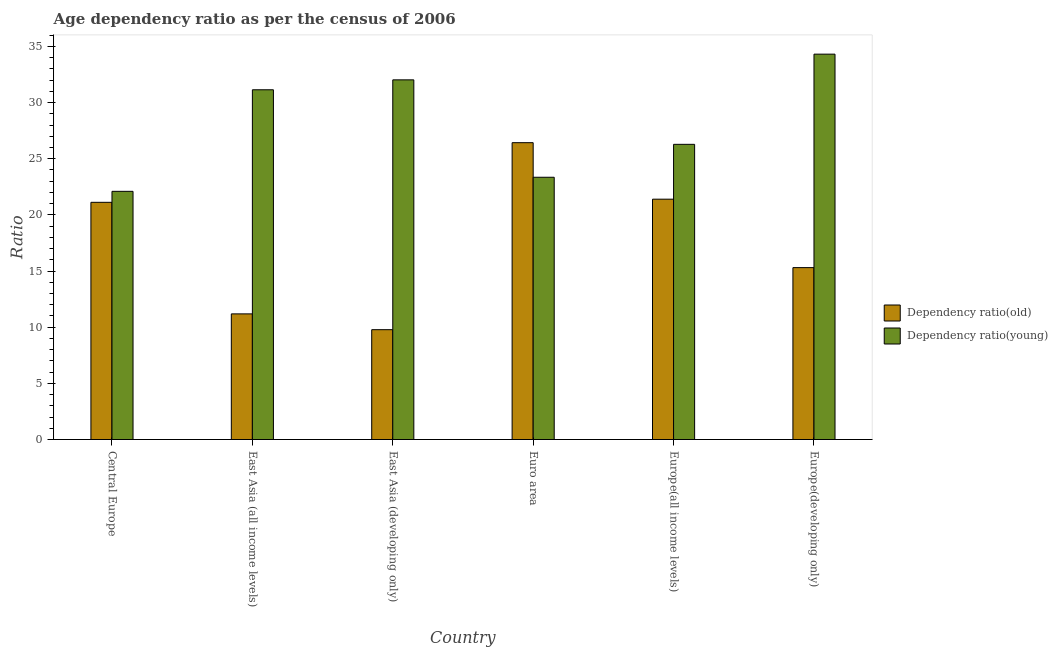How many different coloured bars are there?
Your answer should be compact. 2. How many groups of bars are there?
Ensure brevity in your answer.  6. How many bars are there on the 2nd tick from the left?
Provide a succinct answer. 2. What is the label of the 3rd group of bars from the left?
Keep it short and to the point. East Asia (developing only). In how many cases, is the number of bars for a given country not equal to the number of legend labels?
Your answer should be compact. 0. What is the age dependency ratio(old) in Euro area?
Give a very brief answer. 26.43. Across all countries, what is the maximum age dependency ratio(young)?
Provide a short and direct response. 34.31. Across all countries, what is the minimum age dependency ratio(old)?
Offer a very short reply. 9.78. In which country was the age dependency ratio(old) maximum?
Give a very brief answer. Euro area. In which country was the age dependency ratio(old) minimum?
Give a very brief answer. East Asia (developing only). What is the total age dependency ratio(old) in the graph?
Give a very brief answer. 105.21. What is the difference between the age dependency ratio(old) in Euro area and that in Europe(all income levels)?
Provide a short and direct response. 5.03. What is the difference between the age dependency ratio(young) in Euro area and the age dependency ratio(old) in East Asia (developing only)?
Ensure brevity in your answer.  13.57. What is the average age dependency ratio(old) per country?
Give a very brief answer. 17.54. What is the difference between the age dependency ratio(young) and age dependency ratio(old) in East Asia (developing only)?
Make the answer very short. 22.24. What is the ratio of the age dependency ratio(young) in Europe(all income levels) to that in Europe(developing only)?
Your answer should be compact. 0.77. What is the difference between the highest and the second highest age dependency ratio(young)?
Your answer should be compact. 2.29. What is the difference between the highest and the lowest age dependency ratio(young)?
Your answer should be very brief. 12.21. What does the 1st bar from the left in Euro area represents?
Your answer should be compact. Dependency ratio(old). What does the 1st bar from the right in Europe(all income levels) represents?
Ensure brevity in your answer.  Dependency ratio(young). Are all the bars in the graph horizontal?
Your answer should be very brief. No. How many countries are there in the graph?
Your answer should be very brief. 6. Does the graph contain any zero values?
Give a very brief answer. No. Does the graph contain grids?
Offer a terse response. No. What is the title of the graph?
Offer a terse response. Age dependency ratio as per the census of 2006. Does "Residents" appear as one of the legend labels in the graph?
Your answer should be very brief. No. What is the label or title of the X-axis?
Your response must be concise. Country. What is the label or title of the Y-axis?
Offer a terse response. Ratio. What is the Ratio in Dependency ratio(old) in Central Europe?
Offer a very short reply. 21.12. What is the Ratio of Dependency ratio(young) in Central Europe?
Provide a short and direct response. 22.1. What is the Ratio in Dependency ratio(old) in East Asia (all income levels)?
Give a very brief answer. 11.19. What is the Ratio of Dependency ratio(young) in East Asia (all income levels)?
Offer a terse response. 31.14. What is the Ratio in Dependency ratio(old) in East Asia (developing only)?
Ensure brevity in your answer.  9.78. What is the Ratio in Dependency ratio(young) in East Asia (developing only)?
Offer a terse response. 32.02. What is the Ratio in Dependency ratio(old) in Euro area?
Keep it short and to the point. 26.43. What is the Ratio of Dependency ratio(young) in Euro area?
Give a very brief answer. 23.35. What is the Ratio of Dependency ratio(old) in Europe(all income levels)?
Ensure brevity in your answer.  21.4. What is the Ratio in Dependency ratio(young) in Europe(all income levels)?
Give a very brief answer. 26.28. What is the Ratio in Dependency ratio(old) in Europe(developing only)?
Ensure brevity in your answer.  15.3. What is the Ratio in Dependency ratio(young) in Europe(developing only)?
Give a very brief answer. 34.31. Across all countries, what is the maximum Ratio in Dependency ratio(old)?
Your answer should be compact. 26.43. Across all countries, what is the maximum Ratio of Dependency ratio(young)?
Make the answer very short. 34.31. Across all countries, what is the minimum Ratio in Dependency ratio(old)?
Your answer should be very brief. 9.78. Across all countries, what is the minimum Ratio of Dependency ratio(young)?
Your response must be concise. 22.1. What is the total Ratio of Dependency ratio(old) in the graph?
Keep it short and to the point. 105.21. What is the total Ratio of Dependency ratio(young) in the graph?
Give a very brief answer. 169.19. What is the difference between the Ratio in Dependency ratio(old) in Central Europe and that in East Asia (all income levels)?
Offer a terse response. 9.93. What is the difference between the Ratio of Dependency ratio(young) in Central Europe and that in East Asia (all income levels)?
Make the answer very short. -9.04. What is the difference between the Ratio in Dependency ratio(old) in Central Europe and that in East Asia (developing only)?
Your answer should be compact. 11.34. What is the difference between the Ratio of Dependency ratio(young) in Central Europe and that in East Asia (developing only)?
Your response must be concise. -9.92. What is the difference between the Ratio in Dependency ratio(old) in Central Europe and that in Euro area?
Your answer should be very brief. -5.31. What is the difference between the Ratio of Dependency ratio(young) in Central Europe and that in Euro area?
Your answer should be very brief. -1.25. What is the difference between the Ratio of Dependency ratio(old) in Central Europe and that in Europe(all income levels)?
Your answer should be very brief. -0.28. What is the difference between the Ratio of Dependency ratio(young) in Central Europe and that in Europe(all income levels)?
Offer a very short reply. -4.18. What is the difference between the Ratio in Dependency ratio(old) in Central Europe and that in Europe(developing only)?
Your response must be concise. 5.81. What is the difference between the Ratio in Dependency ratio(young) in Central Europe and that in Europe(developing only)?
Provide a short and direct response. -12.21. What is the difference between the Ratio of Dependency ratio(old) in East Asia (all income levels) and that in East Asia (developing only)?
Keep it short and to the point. 1.41. What is the difference between the Ratio of Dependency ratio(young) in East Asia (all income levels) and that in East Asia (developing only)?
Your answer should be very brief. -0.88. What is the difference between the Ratio of Dependency ratio(old) in East Asia (all income levels) and that in Euro area?
Give a very brief answer. -15.24. What is the difference between the Ratio in Dependency ratio(young) in East Asia (all income levels) and that in Euro area?
Make the answer very short. 7.79. What is the difference between the Ratio in Dependency ratio(old) in East Asia (all income levels) and that in Europe(all income levels)?
Your answer should be very brief. -10.21. What is the difference between the Ratio of Dependency ratio(young) in East Asia (all income levels) and that in Europe(all income levels)?
Provide a succinct answer. 4.86. What is the difference between the Ratio of Dependency ratio(old) in East Asia (all income levels) and that in Europe(developing only)?
Make the answer very short. -4.12. What is the difference between the Ratio in Dependency ratio(young) in East Asia (all income levels) and that in Europe(developing only)?
Provide a short and direct response. -3.17. What is the difference between the Ratio in Dependency ratio(old) in East Asia (developing only) and that in Euro area?
Ensure brevity in your answer.  -16.65. What is the difference between the Ratio of Dependency ratio(young) in East Asia (developing only) and that in Euro area?
Offer a very short reply. 8.67. What is the difference between the Ratio of Dependency ratio(old) in East Asia (developing only) and that in Europe(all income levels)?
Your answer should be compact. -11.62. What is the difference between the Ratio of Dependency ratio(young) in East Asia (developing only) and that in Europe(all income levels)?
Your answer should be very brief. 5.74. What is the difference between the Ratio in Dependency ratio(old) in East Asia (developing only) and that in Europe(developing only)?
Ensure brevity in your answer.  -5.53. What is the difference between the Ratio of Dependency ratio(young) in East Asia (developing only) and that in Europe(developing only)?
Offer a terse response. -2.29. What is the difference between the Ratio in Dependency ratio(old) in Euro area and that in Europe(all income levels)?
Offer a terse response. 5.03. What is the difference between the Ratio in Dependency ratio(young) in Euro area and that in Europe(all income levels)?
Your response must be concise. -2.93. What is the difference between the Ratio in Dependency ratio(old) in Euro area and that in Europe(developing only)?
Make the answer very short. 11.12. What is the difference between the Ratio in Dependency ratio(young) in Euro area and that in Europe(developing only)?
Offer a very short reply. -10.96. What is the difference between the Ratio of Dependency ratio(old) in Europe(all income levels) and that in Europe(developing only)?
Offer a very short reply. 6.09. What is the difference between the Ratio in Dependency ratio(young) in Europe(all income levels) and that in Europe(developing only)?
Your answer should be compact. -8.03. What is the difference between the Ratio in Dependency ratio(old) in Central Europe and the Ratio in Dependency ratio(young) in East Asia (all income levels)?
Provide a succinct answer. -10.02. What is the difference between the Ratio of Dependency ratio(old) in Central Europe and the Ratio of Dependency ratio(young) in East Asia (developing only)?
Keep it short and to the point. -10.9. What is the difference between the Ratio in Dependency ratio(old) in Central Europe and the Ratio in Dependency ratio(young) in Euro area?
Keep it short and to the point. -2.23. What is the difference between the Ratio of Dependency ratio(old) in Central Europe and the Ratio of Dependency ratio(young) in Europe(all income levels)?
Keep it short and to the point. -5.16. What is the difference between the Ratio in Dependency ratio(old) in Central Europe and the Ratio in Dependency ratio(young) in Europe(developing only)?
Keep it short and to the point. -13.19. What is the difference between the Ratio in Dependency ratio(old) in East Asia (all income levels) and the Ratio in Dependency ratio(young) in East Asia (developing only)?
Provide a short and direct response. -20.83. What is the difference between the Ratio of Dependency ratio(old) in East Asia (all income levels) and the Ratio of Dependency ratio(young) in Euro area?
Provide a succinct answer. -12.16. What is the difference between the Ratio of Dependency ratio(old) in East Asia (all income levels) and the Ratio of Dependency ratio(young) in Europe(all income levels)?
Make the answer very short. -15.09. What is the difference between the Ratio in Dependency ratio(old) in East Asia (all income levels) and the Ratio in Dependency ratio(young) in Europe(developing only)?
Provide a succinct answer. -23.12. What is the difference between the Ratio of Dependency ratio(old) in East Asia (developing only) and the Ratio of Dependency ratio(young) in Euro area?
Offer a terse response. -13.57. What is the difference between the Ratio in Dependency ratio(old) in East Asia (developing only) and the Ratio in Dependency ratio(young) in Europe(all income levels)?
Provide a succinct answer. -16.5. What is the difference between the Ratio of Dependency ratio(old) in East Asia (developing only) and the Ratio of Dependency ratio(young) in Europe(developing only)?
Your answer should be very brief. -24.53. What is the difference between the Ratio in Dependency ratio(old) in Euro area and the Ratio in Dependency ratio(young) in Europe(all income levels)?
Your answer should be compact. 0.15. What is the difference between the Ratio of Dependency ratio(old) in Euro area and the Ratio of Dependency ratio(young) in Europe(developing only)?
Provide a short and direct response. -7.88. What is the difference between the Ratio of Dependency ratio(old) in Europe(all income levels) and the Ratio of Dependency ratio(young) in Europe(developing only)?
Provide a short and direct response. -12.91. What is the average Ratio of Dependency ratio(old) per country?
Offer a very short reply. 17.54. What is the average Ratio in Dependency ratio(young) per country?
Give a very brief answer. 28.2. What is the difference between the Ratio of Dependency ratio(old) and Ratio of Dependency ratio(young) in Central Europe?
Your answer should be very brief. -0.98. What is the difference between the Ratio of Dependency ratio(old) and Ratio of Dependency ratio(young) in East Asia (all income levels)?
Your answer should be compact. -19.95. What is the difference between the Ratio of Dependency ratio(old) and Ratio of Dependency ratio(young) in East Asia (developing only)?
Make the answer very short. -22.24. What is the difference between the Ratio in Dependency ratio(old) and Ratio in Dependency ratio(young) in Euro area?
Keep it short and to the point. 3.08. What is the difference between the Ratio in Dependency ratio(old) and Ratio in Dependency ratio(young) in Europe(all income levels)?
Ensure brevity in your answer.  -4.88. What is the difference between the Ratio of Dependency ratio(old) and Ratio of Dependency ratio(young) in Europe(developing only)?
Your response must be concise. -19.01. What is the ratio of the Ratio of Dependency ratio(old) in Central Europe to that in East Asia (all income levels)?
Your answer should be very brief. 1.89. What is the ratio of the Ratio of Dependency ratio(young) in Central Europe to that in East Asia (all income levels)?
Provide a short and direct response. 0.71. What is the ratio of the Ratio of Dependency ratio(old) in Central Europe to that in East Asia (developing only)?
Your response must be concise. 2.16. What is the ratio of the Ratio of Dependency ratio(young) in Central Europe to that in East Asia (developing only)?
Provide a succinct answer. 0.69. What is the ratio of the Ratio in Dependency ratio(old) in Central Europe to that in Euro area?
Your answer should be very brief. 0.8. What is the ratio of the Ratio of Dependency ratio(young) in Central Europe to that in Euro area?
Keep it short and to the point. 0.95. What is the ratio of the Ratio of Dependency ratio(old) in Central Europe to that in Europe(all income levels)?
Your response must be concise. 0.99. What is the ratio of the Ratio of Dependency ratio(young) in Central Europe to that in Europe(all income levels)?
Ensure brevity in your answer.  0.84. What is the ratio of the Ratio in Dependency ratio(old) in Central Europe to that in Europe(developing only)?
Ensure brevity in your answer.  1.38. What is the ratio of the Ratio of Dependency ratio(young) in Central Europe to that in Europe(developing only)?
Offer a very short reply. 0.64. What is the ratio of the Ratio of Dependency ratio(old) in East Asia (all income levels) to that in East Asia (developing only)?
Offer a very short reply. 1.14. What is the ratio of the Ratio in Dependency ratio(young) in East Asia (all income levels) to that in East Asia (developing only)?
Make the answer very short. 0.97. What is the ratio of the Ratio of Dependency ratio(old) in East Asia (all income levels) to that in Euro area?
Keep it short and to the point. 0.42. What is the ratio of the Ratio of Dependency ratio(young) in East Asia (all income levels) to that in Euro area?
Make the answer very short. 1.33. What is the ratio of the Ratio of Dependency ratio(old) in East Asia (all income levels) to that in Europe(all income levels)?
Ensure brevity in your answer.  0.52. What is the ratio of the Ratio of Dependency ratio(young) in East Asia (all income levels) to that in Europe(all income levels)?
Ensure brevity in your answer.  1.18. What is the ratio of the Ratio of Dependency ratio(old) in East Asia (all income levels) to that in Europe(developing only)?
Ensure brevity in your answer.  0.73. What is the ratio of the Ratio of Dependency ratio(young) in East Asia (all income levels) to that in Europe(developing only)?
Provide a short and direct response. 0.91. What is the ratio of the Ratio in Dependency ratio(old) in East Asia (developing only) to that in Euro area?
Keep it short and to the point. 0.37. What is the ratio of the Ratio in Dependency ratio(young) in East Asia (developing only) to that in Euro area?
Offer a terse response. 1.37. What is the ratio of the Ratio in Dependency ratio(old) in East Asia (developing only) to that in Europe(all income levels)?
Your answer should be compact. 0.46. What is the ratio of the Ratio of Dependency ratio(young) in East Asia (developing only) to that in Europe(all income levels)?
Offer a terse response. 1.22. What is the ratio of the Ratio of Dependency ratio(old) in East Asia (developing only) to that in Europe(developing only)?
Keep it short and to the point. 0.64. What is the ratio of the Ratio in Dependency ratio(young) in East Asia (developing only) to that in Europe(developing only)?
Give a very brief answer. 0.93. What is the ratio of the Ratio in Dependency ratio(old) in Euro area to that in Europe(all income levels)?
Provide a short and direct response. 1.24. What is the ratio of the Ratio of Dependency ratio(young) in Euro area to that in Europe(all income levels)?
Give a very brief answer. 0.89. What is the ratio of the Ratio in Dependency ratio(old) in Euro area to that in Europe(developing only)?
Offer a terse response. 1.73. What is the ratio of the Ratio of Dependency ratio(young) in Euro area to that in Europe(developing only)?
Give a very brief answer. 0.68. What is the ratio of the Ratio in Dependency ratio(old) in Europe(all income levels) to that in Europe(developing only)?
Make the answer very short. 1.4. What is the ratio of the Ratio of Dependency ratio(young) in Europe(all income levels) to that in Europe(developing only)?
Your answer should be very brief. 0.77. What is the difference between the highest and the second highest Ratio of Dependency ratio(old)?
Offer a very short reply. 5.03. What is the difference between the highest and the second highest Ratio in Dependency ratio(young)?
Keep it short and to the point. 2.29. What is the difference between the highest and the lowest Ratio in Dependency ratio(old)?
Provide a short and direct response. 16.65. What is the difference between the highest and the lowest Ratio in Dependency ratio(young)?
Keep it short and to the point. 12.21. 